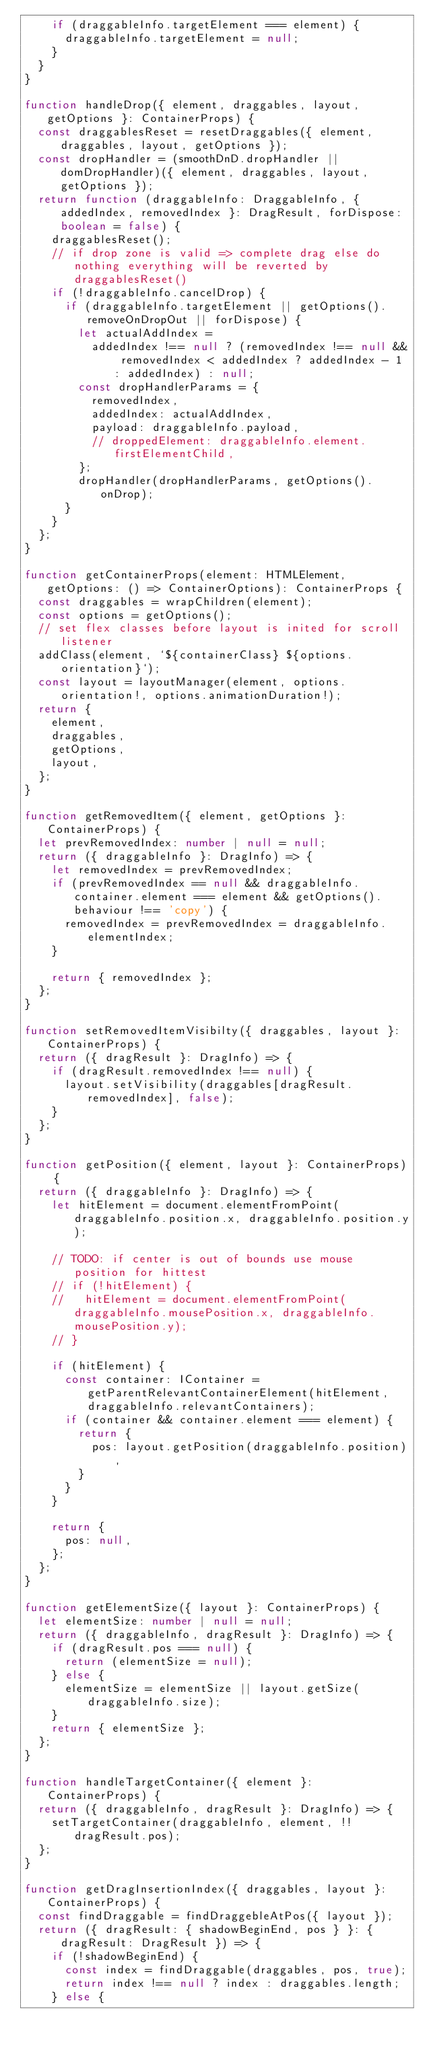<code> <loc_0><loc_0><loc_500><loc_500><_TypeScript_>    if (draggableInfo.targetElement === element) {
      draggableInfo.targetElement = null;
    }
  }
}

function handleDrop({ element, draggables, layout, getOptions }: ContainerProps) {
  const draggablesReset = resetDraggables({ element, draggables, layout, getOptions });
  const dropHandler = (smoothDnD.dropHandler || domDropHandler)({ element, draggables, layout, getOptions });
  return function (draggableInfo: DraggableInfo, { addedIndex, removedIndex }: DragResult, forDispose: boolean = false) {
    draggablesReset();
    // if drop zone is valid => complete drag else do nothing everything will be reverted by draggablesReset()
    if (!draggableInfo.cancelDrop) {
      if (draggableInfo.targetElement || getOptions().removeOnDropOut || forDispose) {
        let actualAddIndex =
          addedIndex !== null ? (removedIndex !== null && removedIndex < addedIndex ? addedIndex - 1 : addedIndex) : null;
        const dropHandlerParams = {
          removedIndex,
          addedIndex: actualAddIndex,
          payload: draggableInfo.payload,
          // droppedElement: draggableInfo.element.firstElementChild,
        };
        dropHandler(dropHandlerParams, getOptions().onDrop);
      }
    }
  };
}

function getContainerProps(element: HTMLElement, getOptions: () => ContainerOptions): ContainerProps {
  const draggables = wrapChildren(element);
  const options = getOptions();
  // set flex classes before layout is inited for scroll listener
  addClass(element, `${containerClass} ${options.orientation}`);
  const layout = layoutManager(element, options.orientation!, options.animationDuration!);
  return {
    element,
    draggables,
    getOptions,
    layout,
  };
}

function getRemovedItem({ element, getOptions }: ContainerProps) {
  let prevRemovedIndex: number | null = null;
  return ({ draggableInfo }: DragInfo) => {
    let removedIndex = prevRemovedIndex;
    if (prevRemovedIndex == null && draggableInfo.container.element === element && getOptions().behaviour !== 'copy') {
      removedIndex = prevRemovedIndex = draggableInfo.elementIndex;
    }

    return { removedIndex };
  };
}

function setRemovedItemVisibilty({ draggables, layout }: ContainerProps) {
  return ({ dragResult }: DragInfo) => {
    if (dragResult.removedIndex !== null) {
      layout.setVisibility(draggables[dragResult.removedIndex], false);
    }
  };
}

function getPosition({ element, layout }: ContainerProps) {
  return ({ draggableInfo }: DragInfo) => {
    let hitElement = document.elementFromPoint(draggableInfo.position.x, draggableInfo.position.y);

    // TODO: if center is out of bounds use mouse position for hittest
    // if (!hitElement) {
    //   hitElement = document.elementFromPoint(draggableInfo.mousePosition.x, draggableInfo.mousePosition.y);
    // }

    if (hitElement) {
      const container: IContainer = getParentRelevantContainerElement(hitElement, draggableInfo.relevantContainers);
      if (container && container.element === element) {
        return {
          pos: layout.getPosition(draggableInfo.position),
        }
      }
    }

    return {
      pos: null,
    };
  };
}

function getElementSize({ layout }: ContainerProps) {
  let elementSize: number | null = null;
  return ({ draggableInfo, dragResult }: DragInfo) => {
    if (dragResult.pos === null) {
      return (elementSize = null);
    } else {
      elementSize = elementSize || layout.getSize(draggableInfo.size);
    }
    return { elementSize };
  };
}

function handleTargetContainer({ element }: ContainerProps) {
  return ({ draggableInfo, dragResult }: DragInfo) => {
    setTargetContainer(draggableInfo, element, !!dragResult.pos);
  };
}

function getDragInsertionIndex({ draggables, layout }: ContainerProps) {
  const findDraggable = findDraggebleAtPos({ layout });
  return ({ dragResult: { shadowBeginEnd, pos } }: { dragResult: DragResult }) => {
    if (!shadowBeginEnd) {
      const index = findDraggable(draggables, pos, true);
      return index !== null ? index : draggables.length;
    } else {</code> 